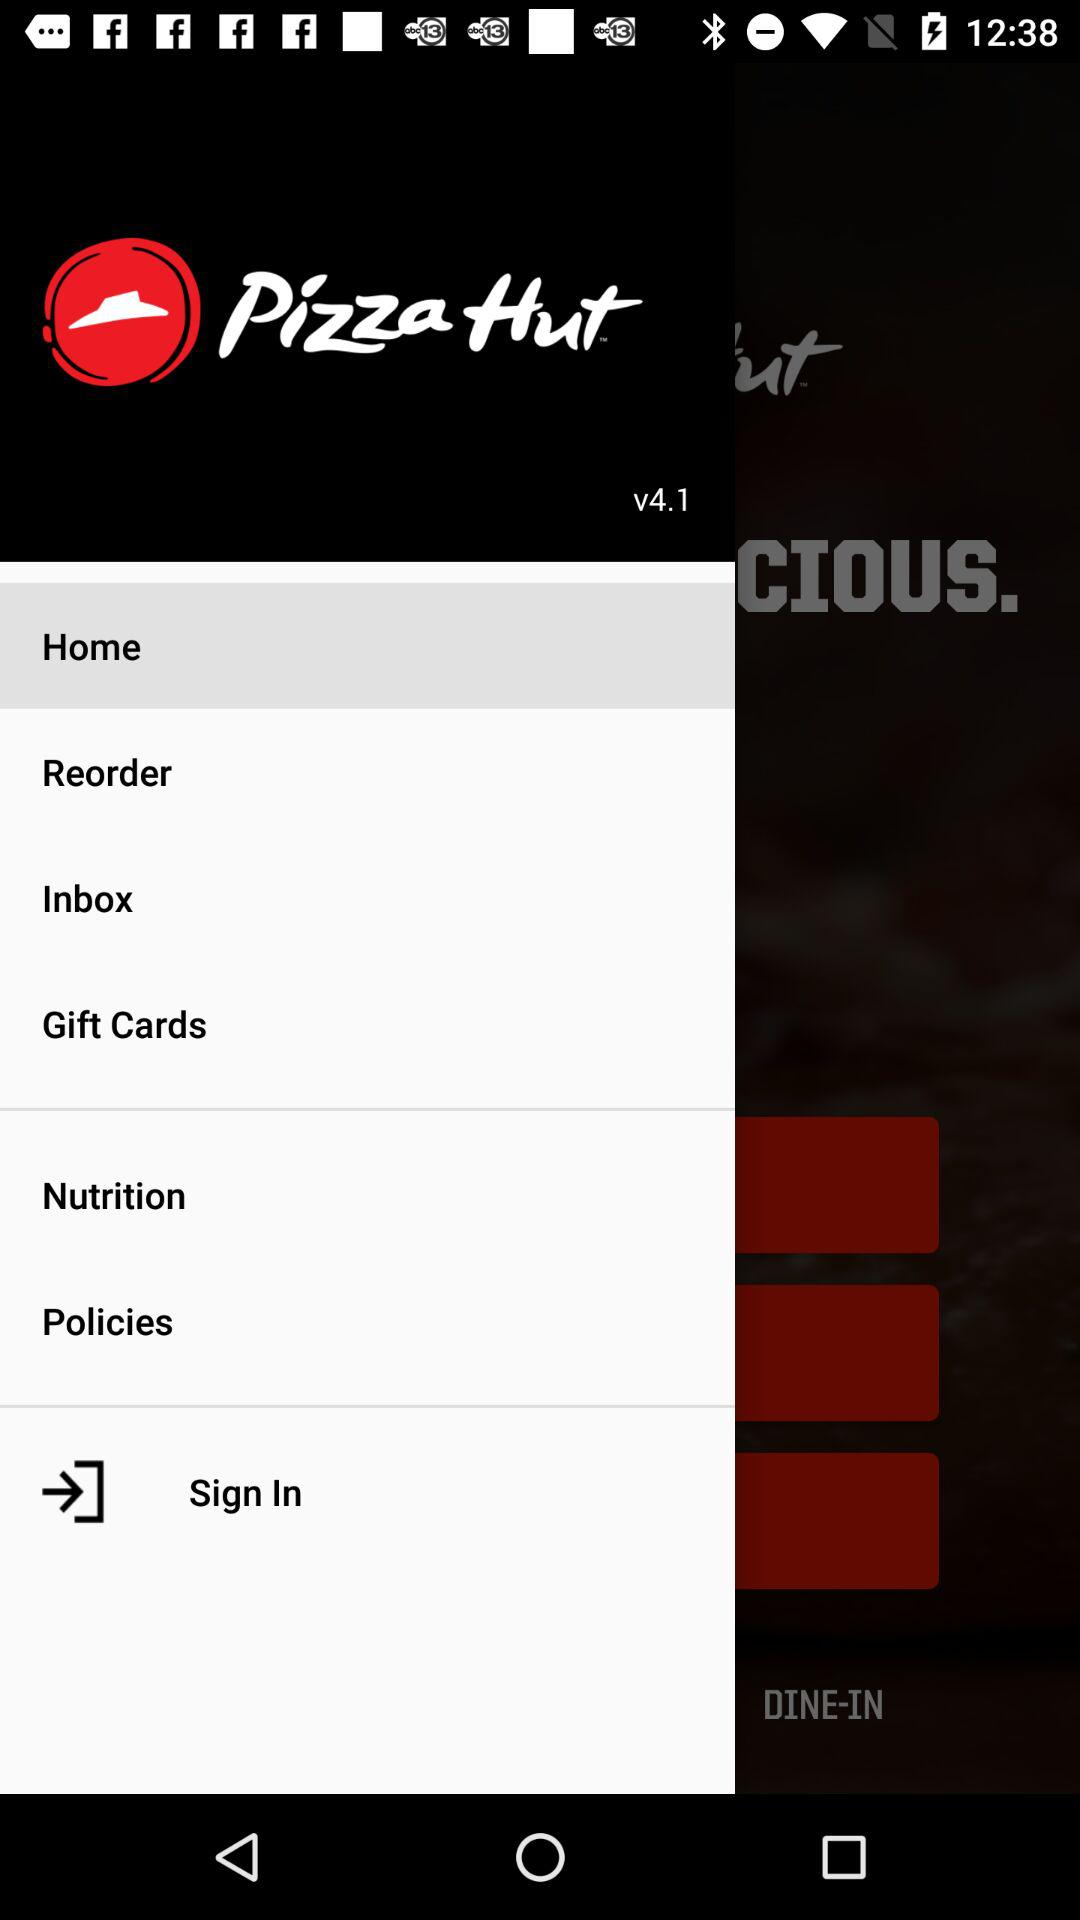What's the application name? The application name is "Pizza Hut". 